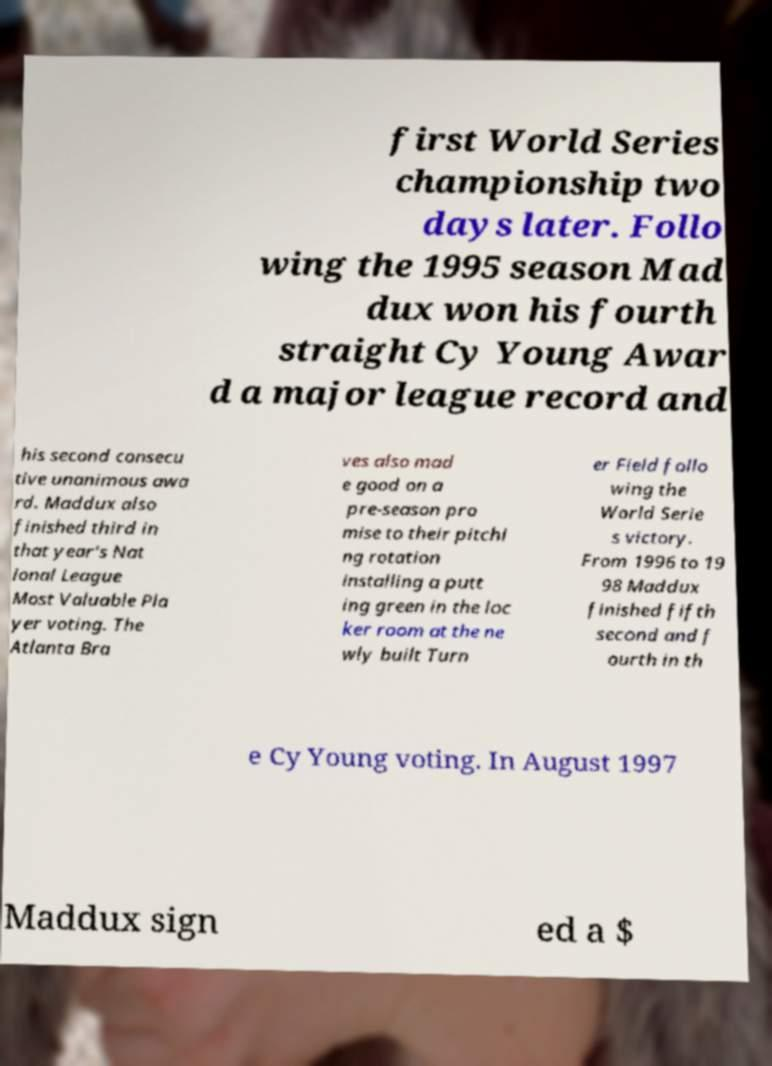Could you extract and type out the text from this image? first World Series championship two days later. Follo wing the 1995 season Mad dux won his fourth straight Cy Young Awar d a major league record and his second consecu tive unanimous awa rd. Maddux also finished third in that year's Nat ional League Most Valuable Pla yer voting. The Atlanta Bra ves also mad e good on a pre-season pro mise to their pitchi ng rotation installing a putt ing green in the loc ker room at the ne wly built Turn er Field follo wing the World Serie s victory. From 1996 to 19 98 Maddux finished fifth second and f ourth in th e Cy Young voting. In August 1997 Maddux sign ed a $ 